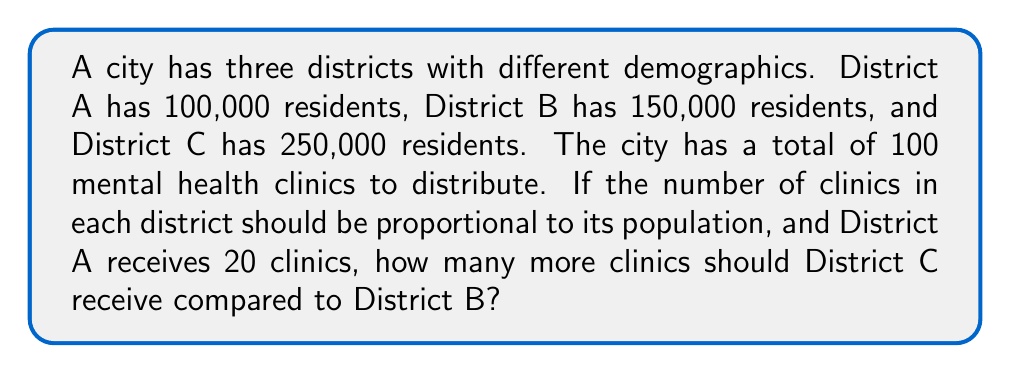Help me with this question. Let's approach this step-by-step:

1) First, let's calculate the total population:
   $100,000 + 150,000 + 250,000 = 500,000$ residents

2) Now, let's find out what proportion of the total population District A represents:
   $\frac{100,000}{500,000} = \frac{1}{5} = 0.2$ or 20%

3) We're told that District A receives 20 clinics. This means that 20 clinics represent 20% of the total clinics. So we can calculate the total number of clinics:
   $20 \div 0.2 = 100$ clinics total

4) Now, let's calculate the proportion of clinics each district should receive:
   District A: $\frac{100,000}{500,000} = 0.2$ or 20%
   District B: $\frac{150,000}{500,000} = 0.3$ or 30%
   District C: $\frac{250,000}{500,000} = 0.5$ or 50%

5) We can now calculate how many clinics each district should receive:
   District A: $0.2 \times 100 = 20$ clinics (which matches what we're told)
   District B: $0.3 \times 100 = 30$ clinics
   District C: $0.5 \times 100 = 50$ clinics

6) The question asks how many more clinics District C should receive compared to District B:
   $50 - 30 = 20$ clinics

Therefore, District C should receive 20 more clinics than District B.
Answer: 20 clinics 